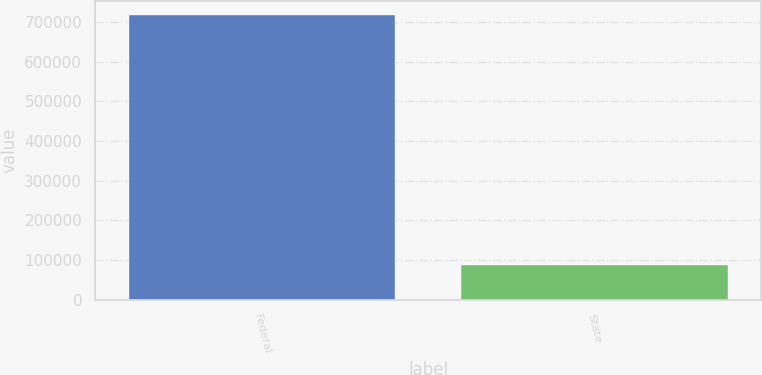Convert chart to OTSL. <chart><loc_0><loc_0><loc_500><loc_500><bar_chart><fcel>Federal<fcel>State<nl><fcel>717109<fcel>87955<nl></chart> 